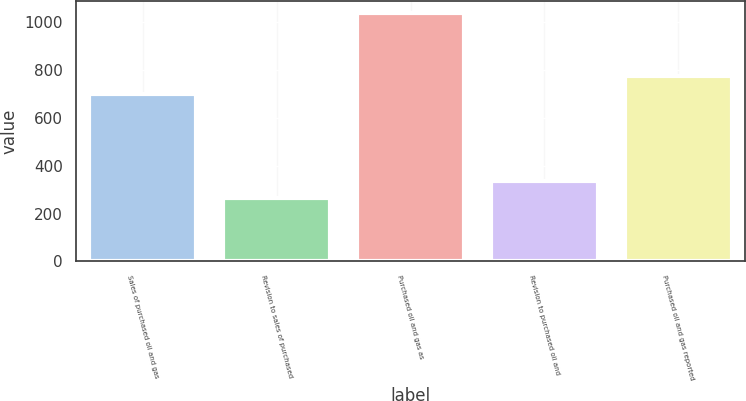Convert chart to OTSL. <chart><loc_0><loc_0><loc_500><loc_500><bar_chart><fcel>Sales of purchased oil and gas<fcel>Revision to sales of purchased<fcel>Purchased oil and gas as<fcel>Revision to purchased oil and<fcel>Purchased oil and gas reported<nl><fcel>700<fcel>264<fcel>1037.9<fcel>337.9<fcel>773.9<nl></chart> 